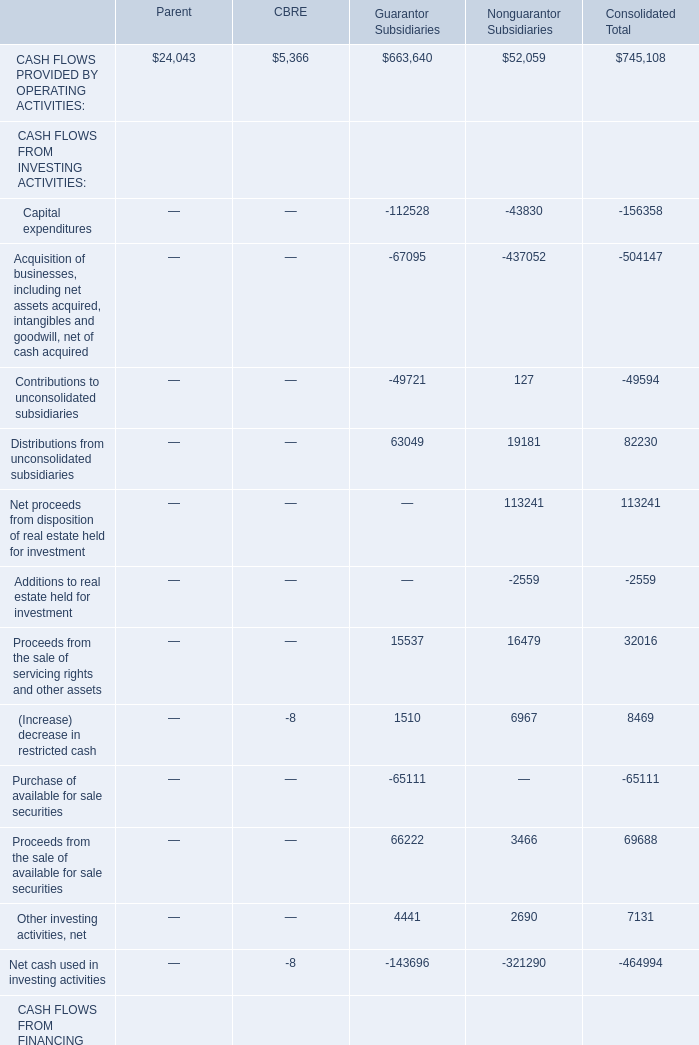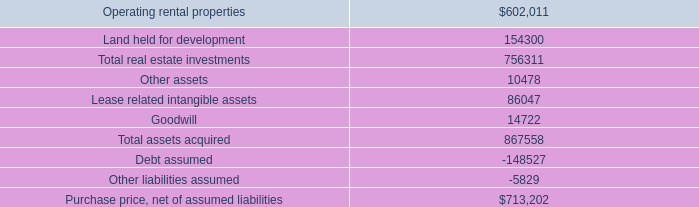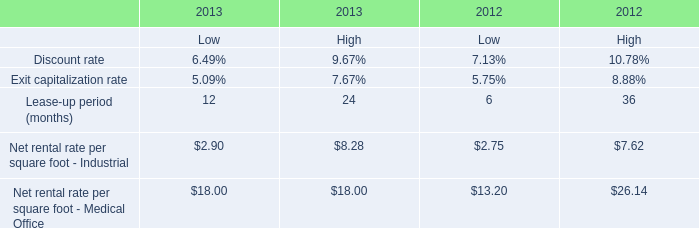goodwill comprises what percentage of total assets acquired? 
Computations: ((14722 / 867558) * 100)
Answer: 1.69695. 